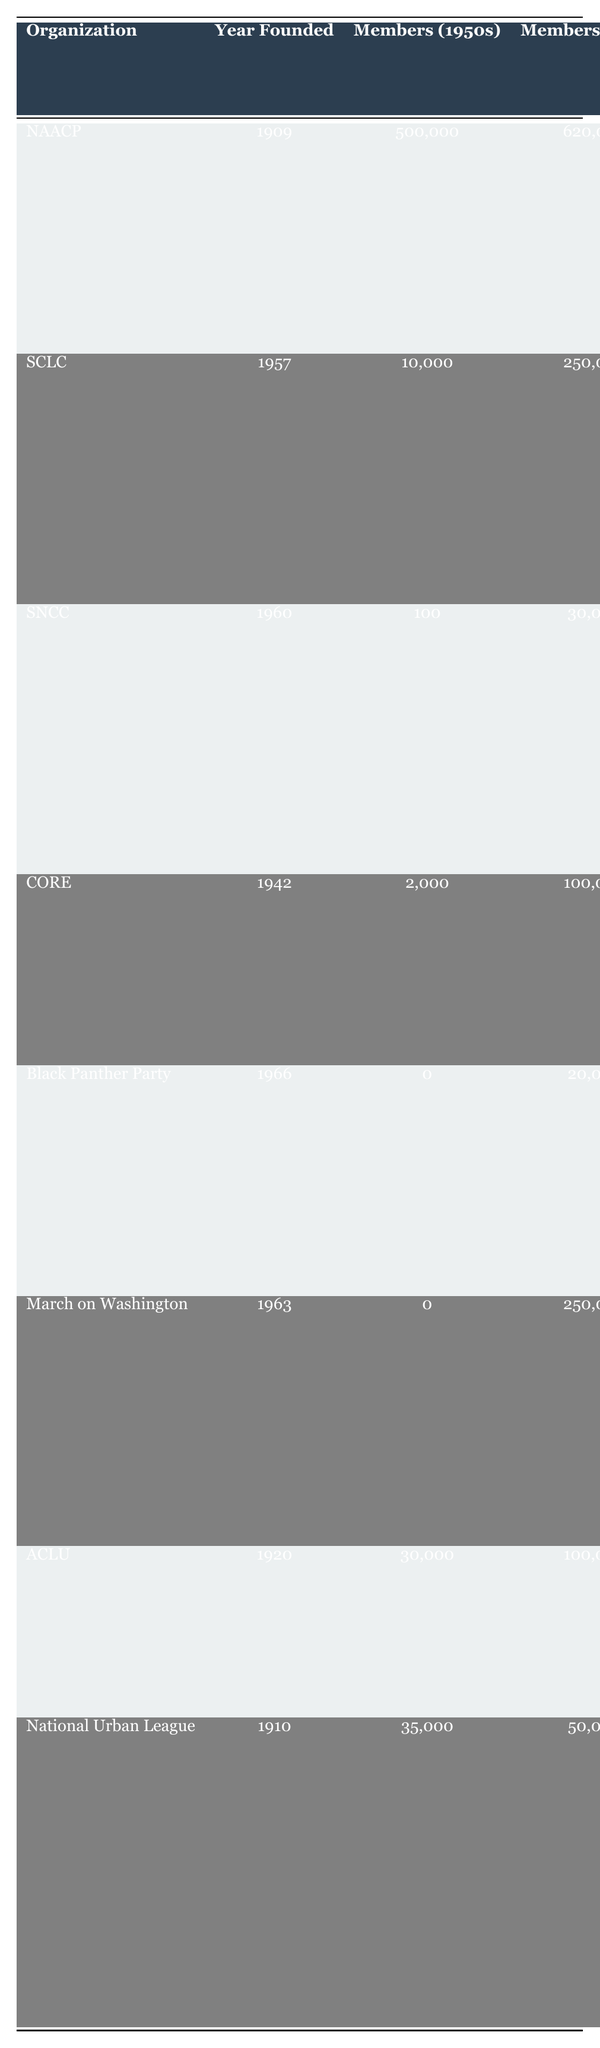What organization had the highest membership in the 1960s? By looking at the "Membership Numbers (1960s)" column, the NAACP shows the highest membership count with 620,000, compared to others in the same column.
Answer: NAACP Which organization was founded the earliest? The "Year Founded" column shows that the NAACP was founded in 1909, earlier than all other organizations listed.
Answer: NAACP What was the membership growth for the SCLC from the 1950s to the 1960s? The membership numbers increased from 10,000 in the 1950s to 250,000 in the 1960s. The growth can be calculated as 250,000 - 10,000 = 240,000.
Answer: 240,000 Did the Black Panther Party have any members in the 1950s? Referring to the "Membership Numbers (1950s)" column, the figure for the Black Panther Party is 0, indicating they had no members in that decade.
Answer: No What was the total membership number of the NAACP and ACLU in the 1960s? To find the total, add the membership of the NAACP (620,000) and ACLU (100,000) in the 1960s: 620,000 + 100,000 = 720,000.
Answer: 720,000 Which organization focused on "Youth Engagement" and what was its membership number in the 1960s? The Student Nonviolent Coordinating Committee (SNCC) focused on "Youth Engagement" and had 30,000 members in the 1960s, as shown in the relevant columns.
Answer: 30,000 How many organizations had membership numbers of 0 in the 1950s? The data shows the Black Panther Party and March on Washington both had 0 members in the 1950s. Therefore, there are 2 organizations with this count.
Answer: 2 What was the average membership number in the 1960s for organizations founded before 1960? The organizations before 1960 are NAACP, SCLC, CORE, ACLU, and National Urban League with membership numbers of 620,000, 250,000, 100,000, 100,000, and 50,000 respectively. The sum is 1,120,000, divided by 5 gives the average: 1,120,000 / 5 = 224,000.
Answer: 224,000 Which organization had the same number of members in the 1950s as the Black Panther Party in the 1960s? In the 1960s, the Black Panther Party had 20,000 members. The CORE had 2,000 in the 1950s, which does not match. The correct match is none because no organization had specifically 20,000 in the 1950s.
Answer: None What was the focus area of the March on Washington for Jobs and Freedom? The table lists its focus areas as "Job Opportunities, Economic Justice, Civil Rights" in the relevant column for focus areas.
Answer: Job Opportunities, Economic Justice, Civil Rights 